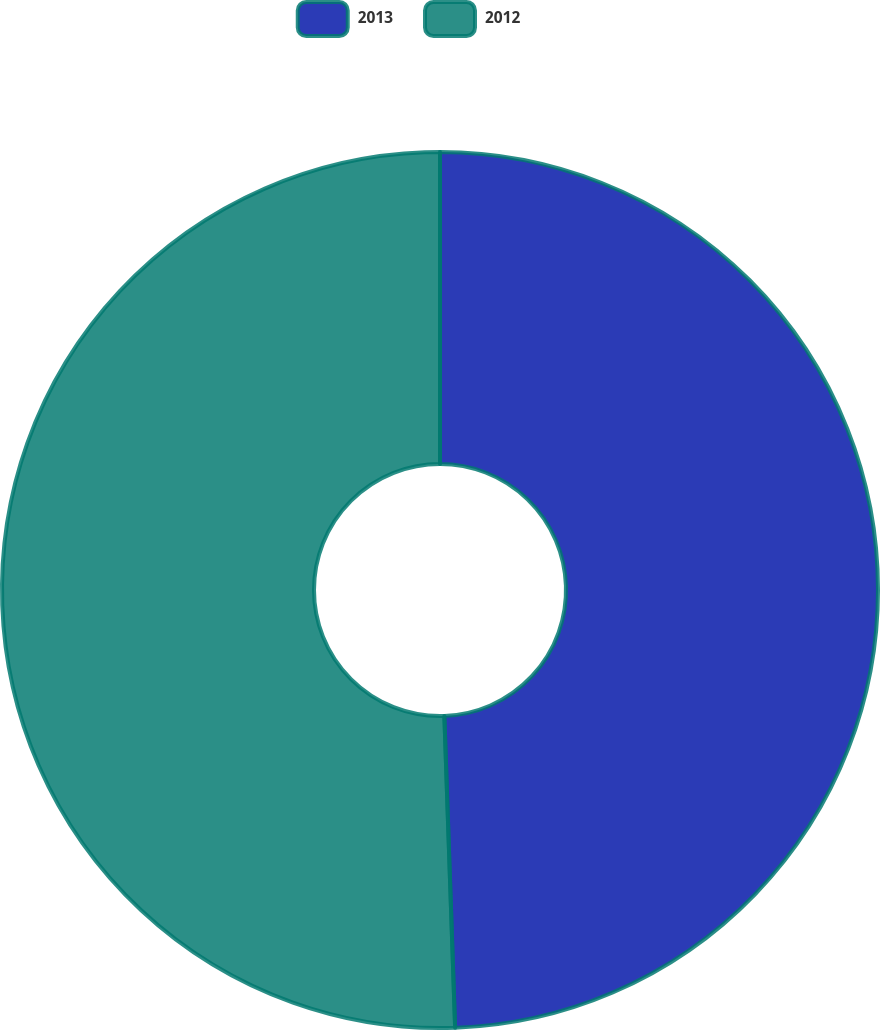Convert chart to OTSL. <chart><loc_0><loc_0><loc_500><loc_500><pie_chart><fcel>2013<fcel>2012<nl><fcel>49.45%<fcel>50.55%<nl></chart> 